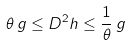<formula> <loc_0><loc_0><loc_500><loc_500>\theta \, g \leq D ^ { 2 } h \leq \frac { 1 } { \theta } \, g</formula> 